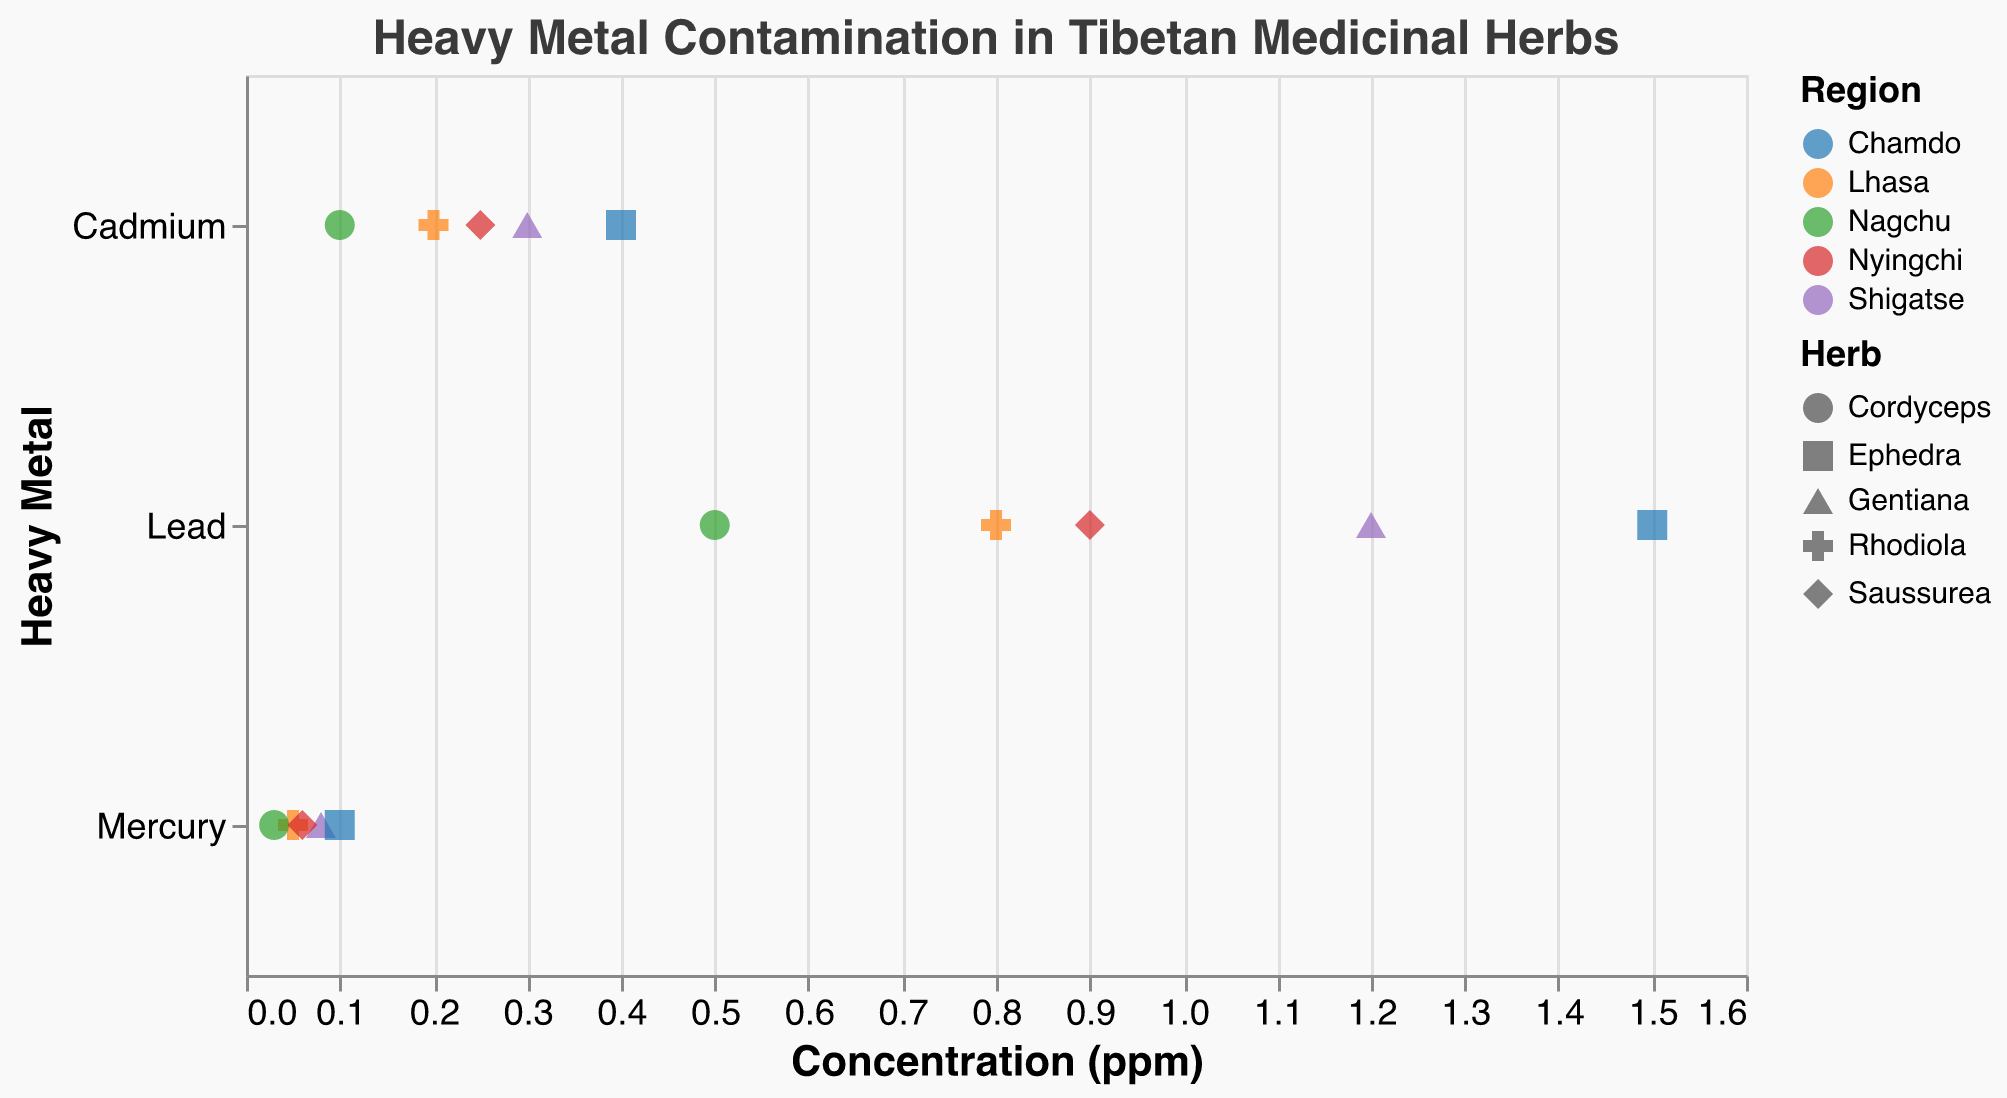What is the highest concentration of lead among all regions? By examining the plot, find the data point with the highest concentration in the Lead group.
Answer: 1.5 ppm Which region has the highest mercury concentration in harvested medicinal herbs? Compare the mercury concentration values for the different regions and identify the highest one.
Answer: Chamdo What is the average concentration of cadmium for herbs in Shigatse? First, locate the cadmium concentrations for herbs from Shigatse in the plot (0.3 ppm). Since there's only one concentration for cadmium in Shigatse, the average is the same.
Answer: 0.3 ppm How do the lead concentrations of herbs from Nyingchi and Lhasa compare? Identify the lead concentrations in both regions: Nyingchi (0.9 ppm) and Lhasa (0.8 ppm). Compare these values.
Answer: Nyingchi has a higher lead concentration Which herb has the lowest mercury concentration and what is that value? Examine the plot for the mercury concentrations and identify the lowest value and its corresponding herb.
Answer: Cordyceps, 0.03 ppm Are there any herbs that have a cadmium concentration above 0.4 ppm? Check the cadmium concentrations for all herbs. Notice if any value exceeds 0.4 ppm.
Answer: No What is the total lead concentration for all herbs from Lhasa? Sum the lead concentrations for Rhodiola from Lhasa (0.8 ppm).
Answer: 0.8 ppm Which herb and region combination has the highest concentration of any single heavy metal? Scan through the plot for the highest concentration value and note its corresponding herb and region.
Answer: Ephedra from Chamdo with 1.5 ppm Lead How does the concentration of mercury in Rhodiola from Lhasa compare to Ephedra from Chamdo? Identify the mercury concentrations for these combinations: Rhodiola from Lhasa (0.05 ppm) and Ephedra from Chamdo (0.1 ppm). Compare these values.
Answer: Ephedra from Chamdo has a higher mercury concentration What is the median concentration of mercury across all regions? List the mercury concentrations: 0.05, 0.08, 0.03, 0.1, 0.06. Arrange these in ascending order (0.03, 0.05, 0.06, 0.08, 0.1). The median is the middle value.
Answer: 0.06 ppm 